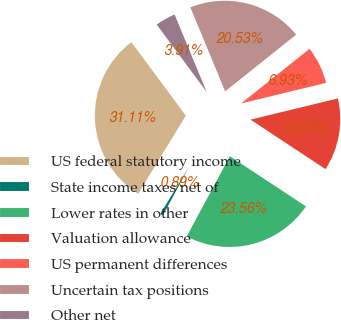Convert chart. <chart><loc_0><loc_0><loc_500><loc_500><pie_chart><fcel>US federal statutory income<fcel>State income taxes net of<fcel>Lower rates in other<fcel>Valuation allowance<fcel>US permanent differences<fcel>Uncertain tax positions<fcel>Other net<nl><fcel>31.11%<fcel>0.89%<fcel>23.56%<fcel>13.07%<fcel>6.93%<fcel>20.53%<fcel>3.91%<nl></chart> 